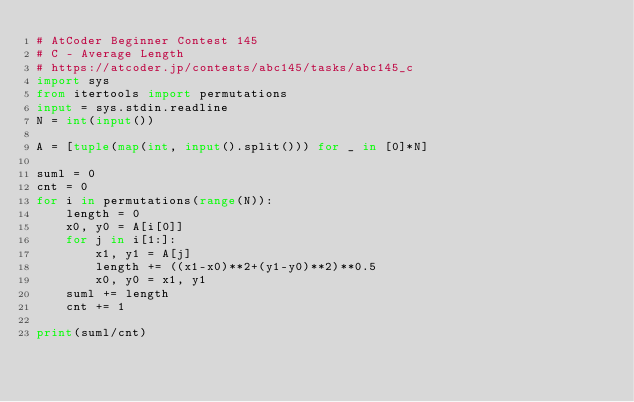<code> <loc_0><loc_0><loc_500><loc_500><_Python_># AtCoder Beginner Contest 145
# C - Average Length
# https://atcoder.jp/contests/abc145/tasks/abc145_c
import sys
from itertools import permutations
input = sys.stdin.readline
N = int(input())

A = [tuple(map(int, input().split())) for _ in [0]*N]

suml = 0
cnt = 0
for i in permutations(range(N)):
    length = 0
    x0, y0 = A[i[0]]
    for j in i[1:]:
        x1, y1 = A[j]
        length += ((x1-x0)**2+(y1-y0)**2)**0.5
        x0, y0 = x1, y1
    suml += length
    cnt += 1

print(suml/cnt)
</code> 